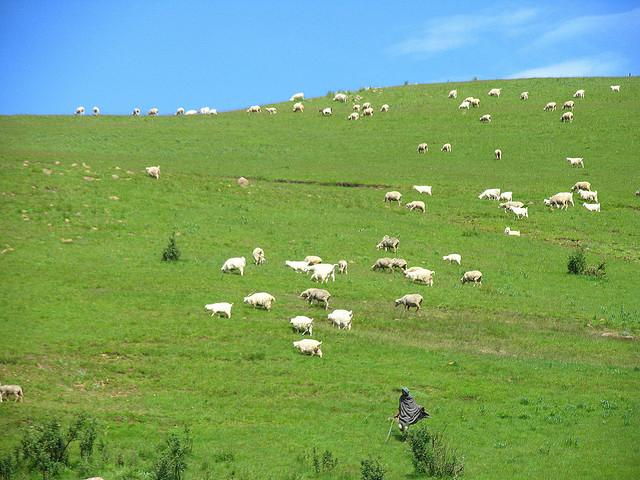What might the man be attempting to do with the animals?

Choices:
A) herd them
B) sheer them
C) hunt them
D) ride them herd them 